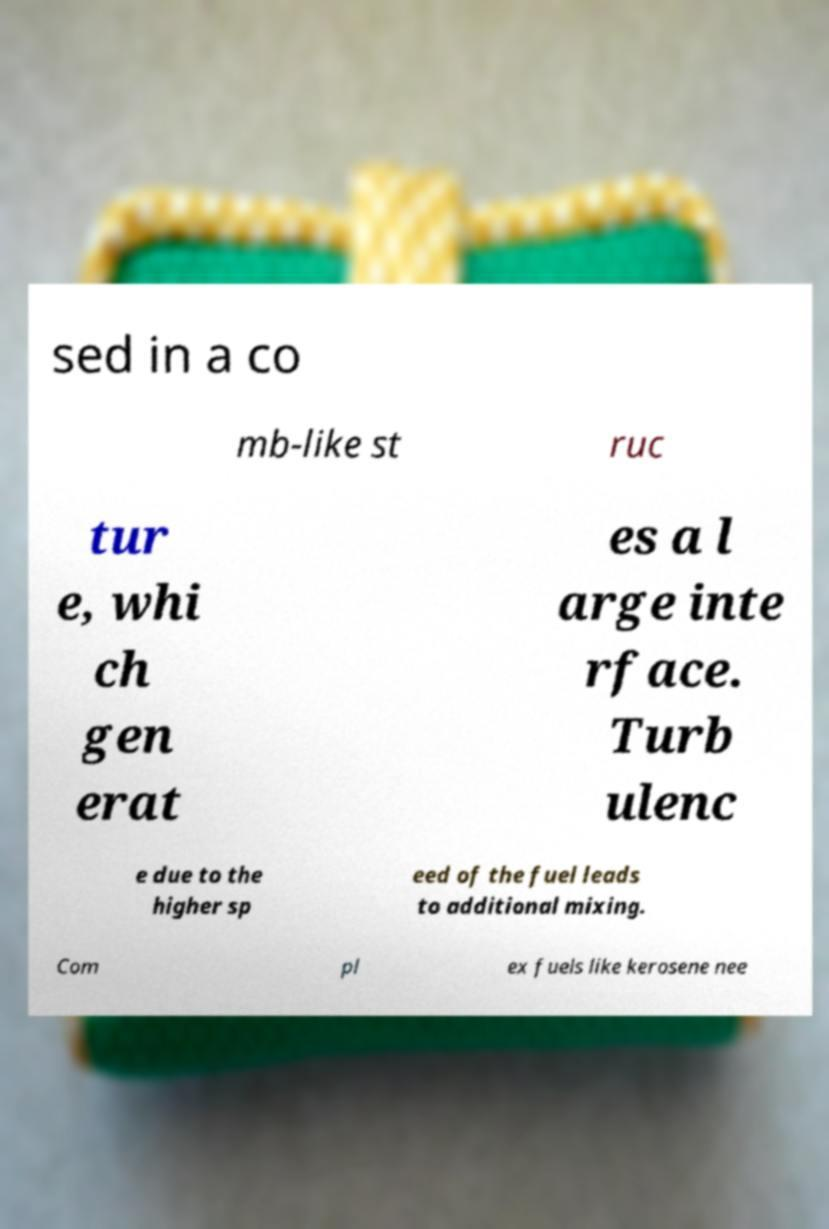Can you read and provide the text displayed in the image?This photo seems to have some interesting text. Can you extract and type it out for me? sed in a co mb-like st ruc tur e, whi ch gen erat es a l arge inte rface. Turb ulenc e due to the higher sp eed of the fuel leads to additional mixing. Com pl ex fuels like kerosene nee 